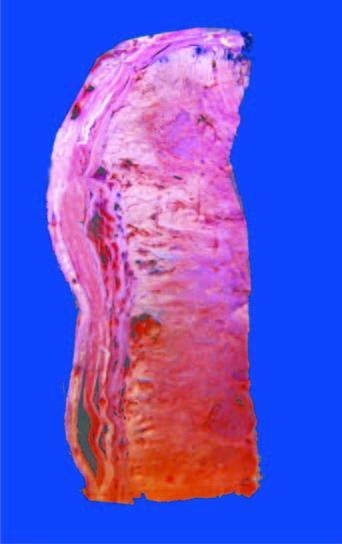what is largely extending into soft tissues including the skeletal muscle?
Answer the question using a single word or phrase. Tumour 